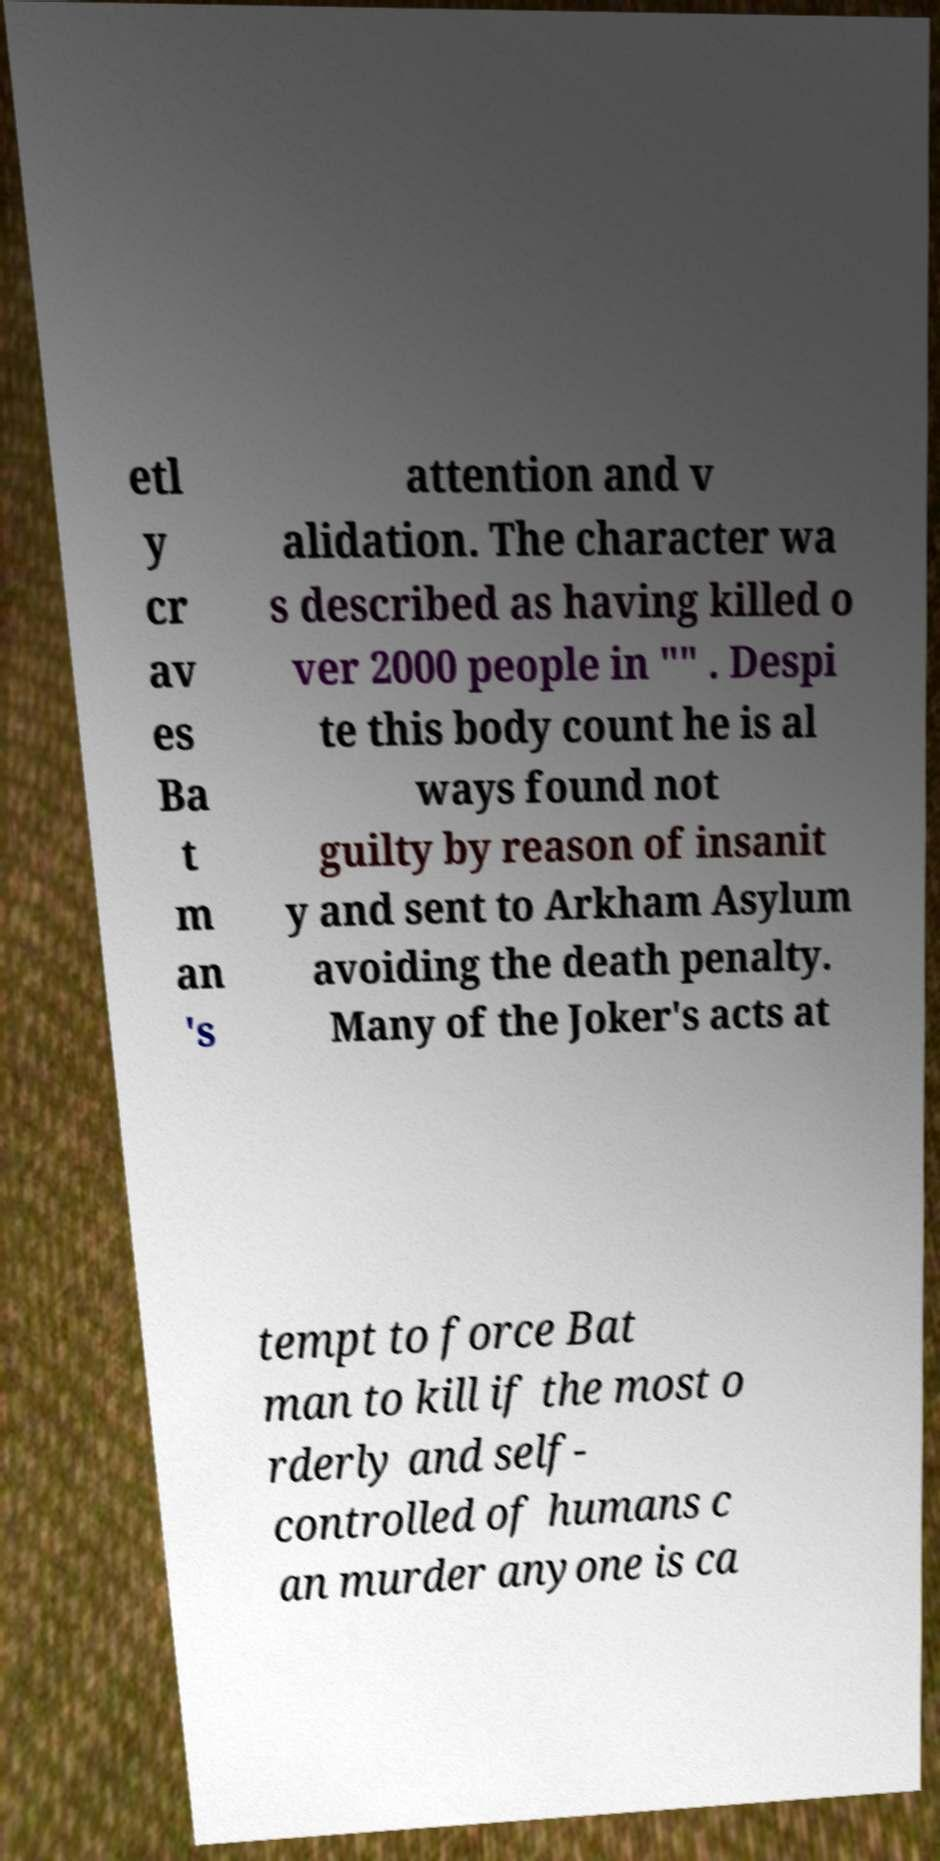Could you assist in decoding the text presented in this image and type it out clearly? etl y cr av es Ba t m an 's attention and v alidation. The character wa s described as having killed o ver 2000 people in "" . Despi te this body count he is al ways found not guilty by reason of insanit y and sent to Arkham Asylum avoiding the death penalty. Many of the Joker's acts at tempt to force Bat man to kill if the most o rderly and self- controlled of humans c an murder anyone is ca 